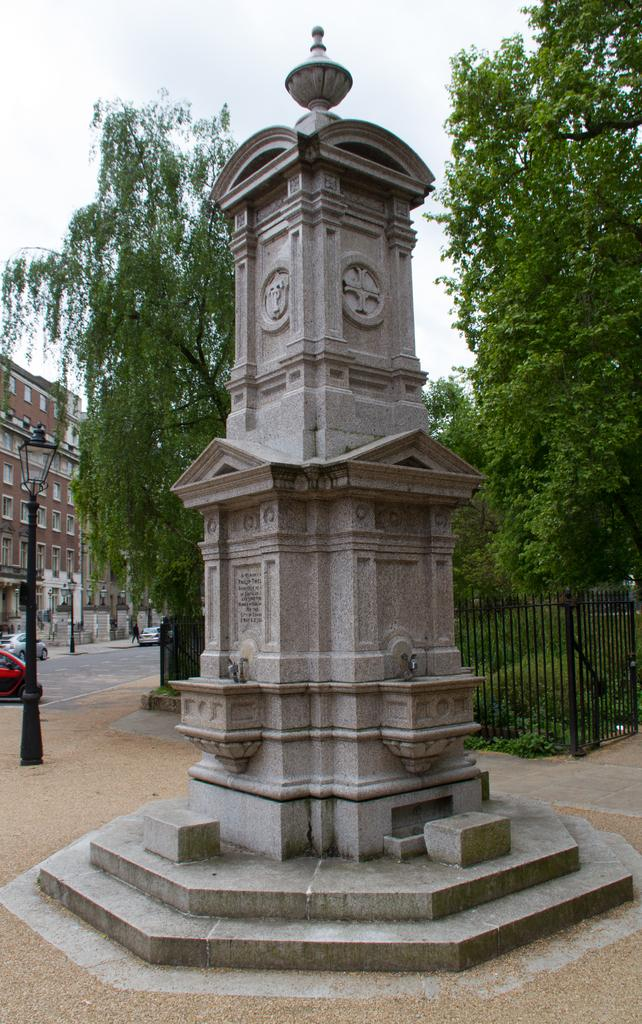What is the main subject in the image? There is a monument in the image. What can be seen in the background of the image? In the background of the image, there is fencing, trees, buildings, and vehicles moving on the road. Can you describe the type of fencing in the image? The fencing in the image is not specified, but it is visible in the background. What type of structures are present in the background of the image? In the background of the image, there are trees and buildings. What type of metal is the cub made of in the image? There is no cub present in the image, so it is not possible to determine the type of metal it might be made of. 